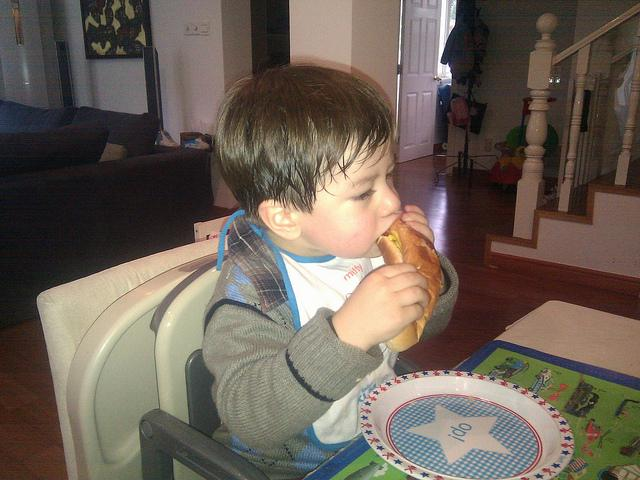What color is the plaid pattern around the star on top of the plate? Please explain your reasoning. blue. That color is similar to that of the sky. 